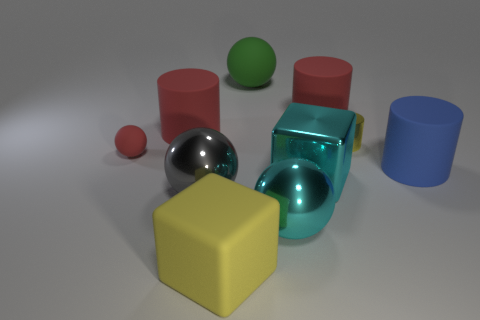How many blocks are made of the same material as the small ball?
Ensure brevity in your answer.  1. What number of things are either spheres that are in front of the gray shiny sphere or large cyan things?
Your response must be concise. 2. Is the number of small matte spheres behind the tiny metallic thing less than the number of things that are on the left side of the cyan block?
Provide a short and direct response. Yes. There is a large gray ball; are there any big red cylinders behind it?
Your response must be concise. Yes. What number of things are either rubber cylinders behind the small red sphere or cyan objects that are in front of the cyan metallic block?
Make the answer very short. 3. How many large rubber objects are the same color as the tiny metal thing?
Make the answer very short. 1. There is another small object that is the same shape as the green matte object; what color is it?
Your answer should be compact. Red. There is a large rubber thing that is behind the large yellow matte cube and on the left side of the green object; what is its shape?
Give a very brief answer. Cylinder. Are there more big brown matte blocks than big rubber things?
Offer a terse response. No. What is the cyan cube made of?
Your response must be concise. Metal. 